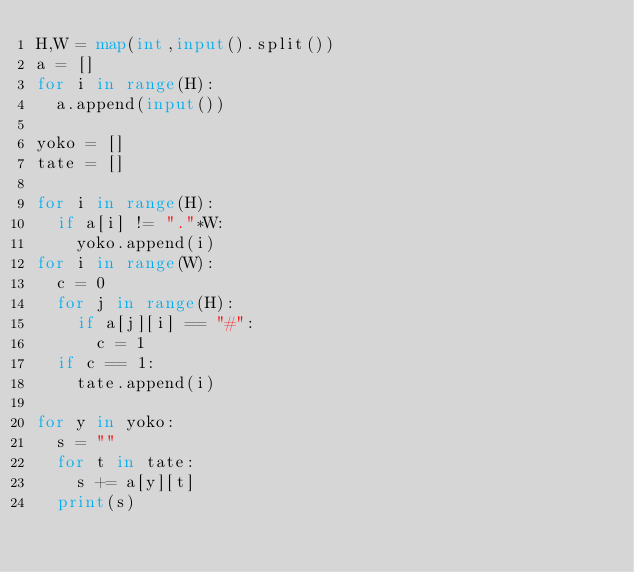<code> <loc_0><loc_0><loc_500><loc_500><_Python_>H,W = map(int,input().split())
a = []
for i in range(H):
  a.append(input())

yoko = []
tate = []

for i in range(H):
  if a[i] != "."*W:
    yoko.append(i)
for i in range(W):
  c = 0
  for j in range(H):
    if a[j][i] == "#":
      c = 1
  if c == 1:
    tate.append(i)

for y in yoko:
  s = ""
  for t in tate:
    s += a[y][t]
  print(s)  </code> 